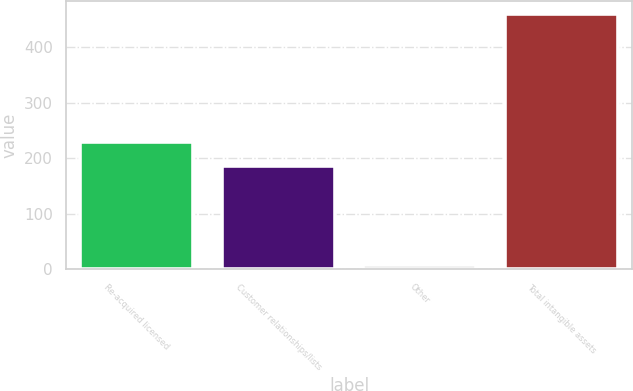<chart> <loc_0><loc_0><loc_500><loc_500><bar_chart><fcel>Re-acquired licensed<fcel>Customer relationships/lists<fcel>Other<fcel>Total intangible assets<nl><fcel>228.59<fcel>186.7<fcel>7.4<fcel>459.49<nl></chart> 